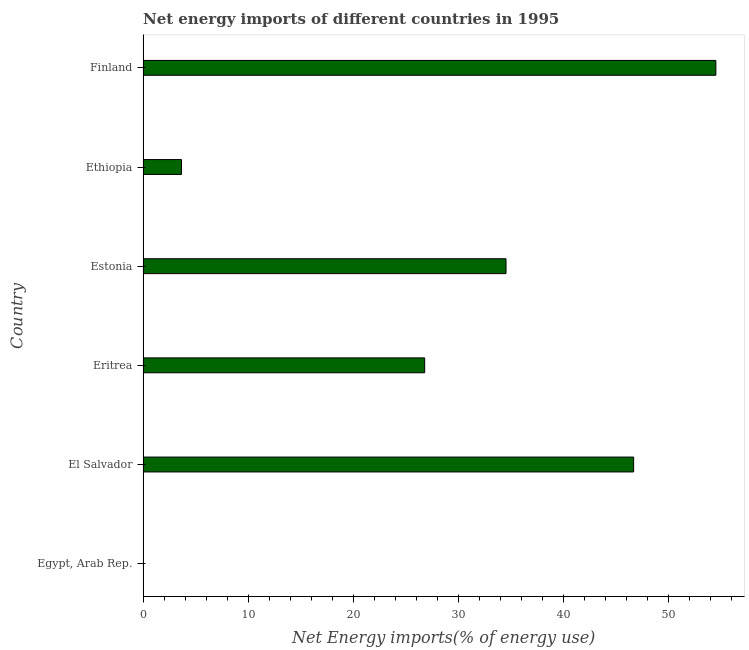Does the graph contain any zero values?
Offer a very short reply. Yes. Does the graph contain grids?
Your answer should be compact. No. What is the title of the graph?
Keep it short and to the point. Net energy imports of different countries in 1995. What is the label or title of the X-axis?
Offer a terse response. Net Energy imports(% of energy use). What is the label or title of the Y-axis?
Offer a terse response. Country. What is the energy imports in Estonia?
Provide a short and direct response. 34.53. Across all countries, what is the maximum energy imports?
Your answer should be compact. 54.5. What is the sum of the energy imports?
Ensure brevity in your answer.  166.15. What is the difference between the energy imports in Ethiopia and Finland?
Your response must be concise. -50.84. What is the average energy imports per country?
Offer a very short reply. 27.69. What is the median energy imports?
Offer a very short reply. 30.66. What is the ratio of the energy imports in Ethiopia to that in Finland?
Ensure brevity in your answer.  0.07. Is the difference between the energy imports in Eritrea and Finland greater than the difference between any two countries?
Make the answer very short. No. What is the difference between the highest and the second highest energy imports?
Offer a terse response. 7.82. Is the sum of the energy imports in Eritrea and Finland greater than the maximum energy imports across all countries?
Give a very brief answer. Yes. What is the difference between the highest and the lowest energy imports?
Provide a short and direct response. 54.5. Are all the bars in the graph horizontal?
Ensure brevity in your answer.  Yes. What is the difference between two consecutive major ticks on the X-axis?
Provide a succinct answer. 10. What is the Net Energy imports(% of energy use) in Egypt, Arab Rep.?
Make the answer very short. 0. What is the Net Energy imports(% of energy use) of El Salvador?
Give a very brief answer. 46.67. What is the Net Energy imports(% of energy use) in Eritrea?
Offer a very short reply. 26.79. What is the Net Energy imports(% of energy use) of Estonia?
Ensure brevity in your answer.  34.53. What is the Net Energy imports(% of energy use) of Ethiopia?
Offer a terse response. 3.66. What is the Net Energy imports(% of energy use) of Finland?
Ensure brevity in your answer.  54.5. What is the difference between the Net Energy imports(% of energy use) in El Salvador and Eritrea?
Ensure brevity in your answer.  19.88. What is the difference between the Net Energy imports(% of energy use) in El Salvador and Estonia?
Provide a short and direct response. 12.14. What is the difference between the Net Energy imports(% of energy use) in El Salvador and Ethiopia?
Make the answer very short. 43.02. What is the difference between the Net Energy imports(% of energy use) in El Salvador and Finland?
Give a very brief answer. -7.82. What is the difference between the Net Energy imports(% of energy use) in Eritrea and Estonia?
Your answer should be compact. -7.74. What is the difference between the Net Energy imports(% of energy use) in Eritrea and Ethiopia?
Provide a short and direct response. 23.14. What is the difference between the Net Energy imports(% of energy use) in Eritrea and Finland?
Your answer should be very brief. -27.7. What is the difference between the Net Energy imports(% of energy use) in Estonia and Ethiopia?
Offer a very short reply. 30.88. What is the difference between the Net Energy imports(% of energy use) in Estonia and Finland?
Ensure brevity in your answer.  -19.97. What is the difference between the Net Energy imports(% of energy use) in Ethiopia and Finland?
Your response must be concise. -50.84. What is the ratio of the Net Energy imports(% of energy use) in El Salvador to that in Eritrea?
Provide a short and direct response. 1.74. What is the ratio of the Net Energy imports(% of energy use) in El Salvador to that in Estonia?
Ensure brevity in your answer.  1.35. What is the ratio of the Net Energy imports(% of energy use) in El Salvador to that in Ethiopia?
Give a very brief answer. 12.77. What is the ratio of the Net Energy imports(% of energy use) in El Salvador to that in Finland?
Provide a succinct answer. 0.86. What is the ratio of the Net Energy imports(% of energy use) in Eritrea to that in Estonia?
Your answer should be very brief. 0.78. What is the ratio of the Net Energy imports(% of energy use) in Eritrea to that in Ethiopia?
Your response must be concise. 7.33. What is the ratio of the Net Energy imports(% of energy use) in Eritrea to that in Finland?
Keep it short and to the point. 0.49. What is the ratio of the Net Energy imports(% of energy use) in Estonia to that in Ethiopia?
Offer a terse response. 9.45. What is the ratio of the Net Energy imports(% of energy use) in Estonia to that in Finland?
Provide a succinct answer. 0.63. What is the ratio of the Net Energy imports(% of energy use) in Ethiopia to that in Finland?
Give a very brief answer. 0.07. 